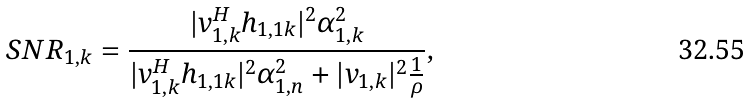Convert formula to latex. <formula><loc_0><loc_0><loc_500><loc_500>& S N R _ { 1 , k } = \frac { | v _ { 1 , k } ^ { H } h _ { 1 , 1 k } | ^ { 2 } \alpha _ { 1 , k } ^ { 2 } } { | v _ { 1 , k } ^ { H } h _ { 1 , 1 k } | ^ { 2 } \alpha _ { 1 , n } ^ { 2 } + | v _ { 1 , k } | ^ { 2 } \frac { 1 } { \rho } } ,</formula> 